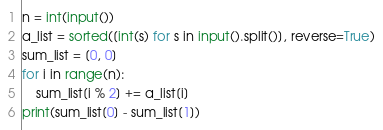<code> <loc_0><loc_0><loc_500><loc_500><_Python_>n = int(input())
a_list = sorted([int(s) for s in input().split()], reverse=True)
sum_list = [0, 0]
for i in range(n):
    sum_list[i % 2] += a_list[i]
print(sum_list[0] - sum_list[1])</code> 